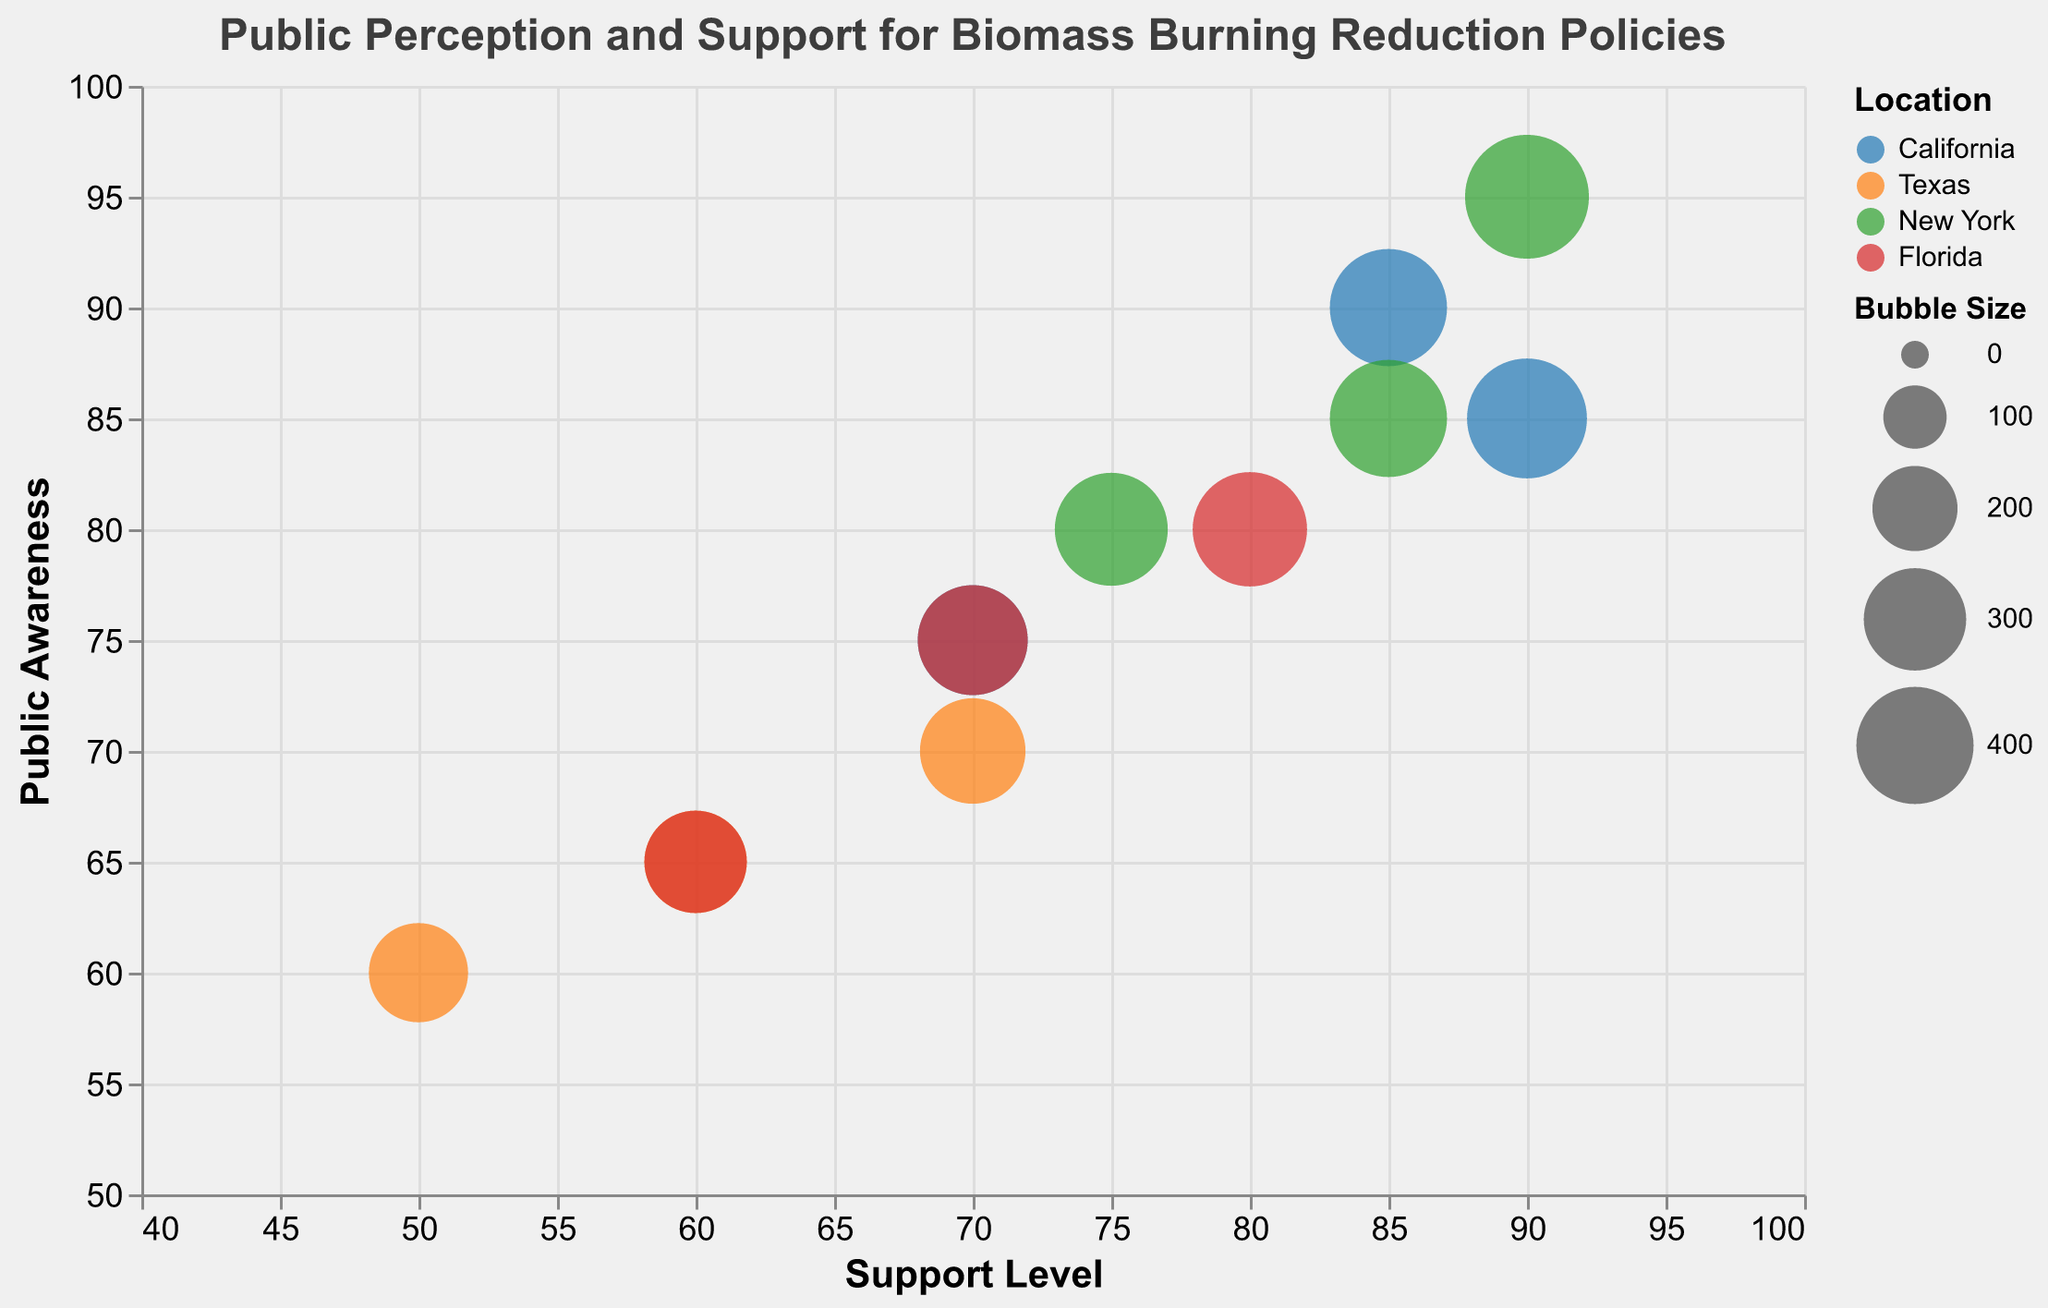What policies have the highest support level in California? The policy with the highest support level in California is identified by looking for the largest value on the x-axis within the "California" group. Here, "Incentives for Clean Energy Transition" has the highest support level at 90.
Answer: Incentives for Clean Energy Transition Which location has the highest public awareness for "Policy to Reduce Biomass Burning"? To find this, locate the bubbles associated with "Policy to Reduce Biomass Burning" and compare their y-axis values. "New York" has the highest public awareness at 95.
Answer: New York How does public awareness for "Increased Fines for Illegal Burning" in Texas compare to that in Florida? Check the y-axis positions for "Increased Fines for Illegal Burning" in Texas and Florida. Texas has 60, and Florida has 65, so public awareness in Florida is higher by 5 points.
Answer: Florida has higher public awareness by 5 points What is the average support level for policies aimed at reducing biomass burning in New York? First, identify the support levels for all policies in New York: 90, 75, 85. Then compute the average: (90 + 75 + 85) / 3 = 83.33.
Answer: 83.33 Which combination of support level and public awareness do "Policy to Reduce Biomass Burning" in California and "Incentives for Clean Energy Transition" in New York share? Check the x and y values for the mentioned categories. "Policy to Reduce Biomass Burning" in California has (85, 90), while "Incentives for Clean Energy Transition" in New York has (85, 85). Thus, both have the same support level of 85.
Answer: Support level of 85 What are the largest and smallest bubble sizes in the chart, and which policies do they represent? The largest and smallest bubbles can be found by looking at the Bubble Size field. The largest is 450 ("Policy to Reduce Biomass Burning" in New York), and the smallest is 280 ("Increased Fines for Illegal Burning" in Texas).
Answer: Largest: Policy to Reduce Biomass Burning in New York; Smallest: Increased Fines for Illegal Burning in Texas How does the importance of "Increased Fines for Illegal Burning" in Florida compare to the same policy in California? Compare the "Importance" values for "Increased Fines for Illegal Burning" in both states. Florida's importance is 7, while California's is 8.
Answer: California's importance is higher by 1 point Which location has the highest combination of support level and public awareness for the "Increased Fines for Illegal Burning" policy? Examine the sum of support level and public awareness for all instances of "Increased Fines for Illegal Burning"; New York has the highest combined value with 75 (support level) + 80 (public awareness) = 155.
Answer: New York When comparing "Policy to Reduce Biomass Burning," which state has the least support level and what is this value? Look for the bubble related to "Policy to Reduce Biomass Burning" with the smallest x-axis value. Texas has the least support level at 60.
Answer: Texas with a support level of 60 